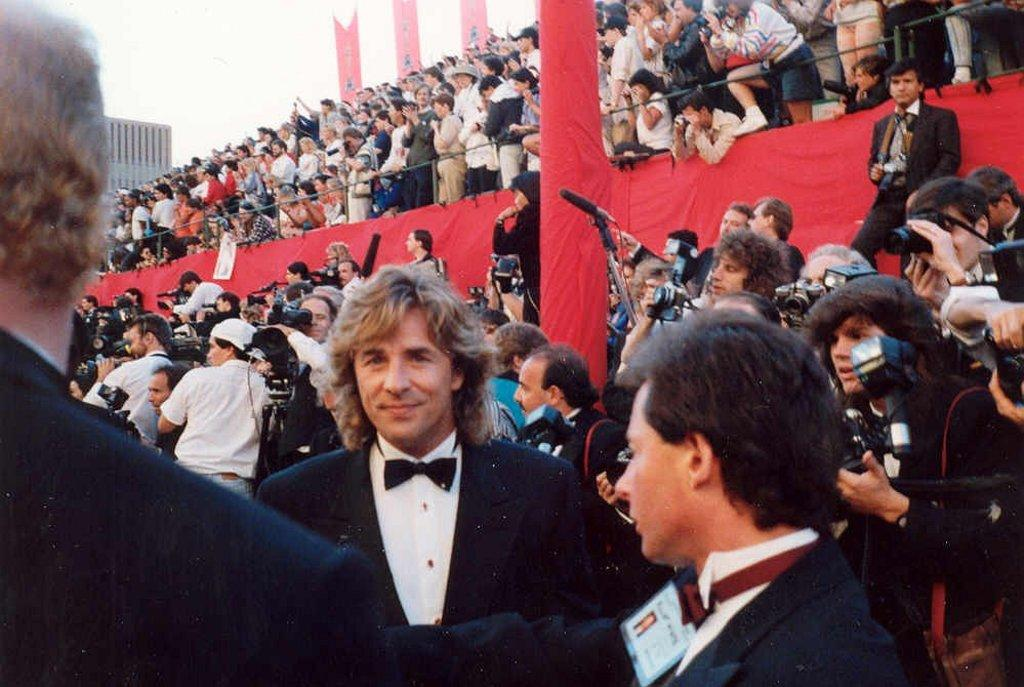How many persons can be seen in the image? There are persons in the image, but the exact number is not specified. What are the persons holding in their hands? The persons are holding cameras with their hands. What can be seen in the background of the image? There is a building, banners, and the sky visible in the background of the image. Is there a volcano erupting in the background of the image? No, there is no volcano present in the image. Can you tell me the condition of the hospital in the image? There is no hospital present in the image. 